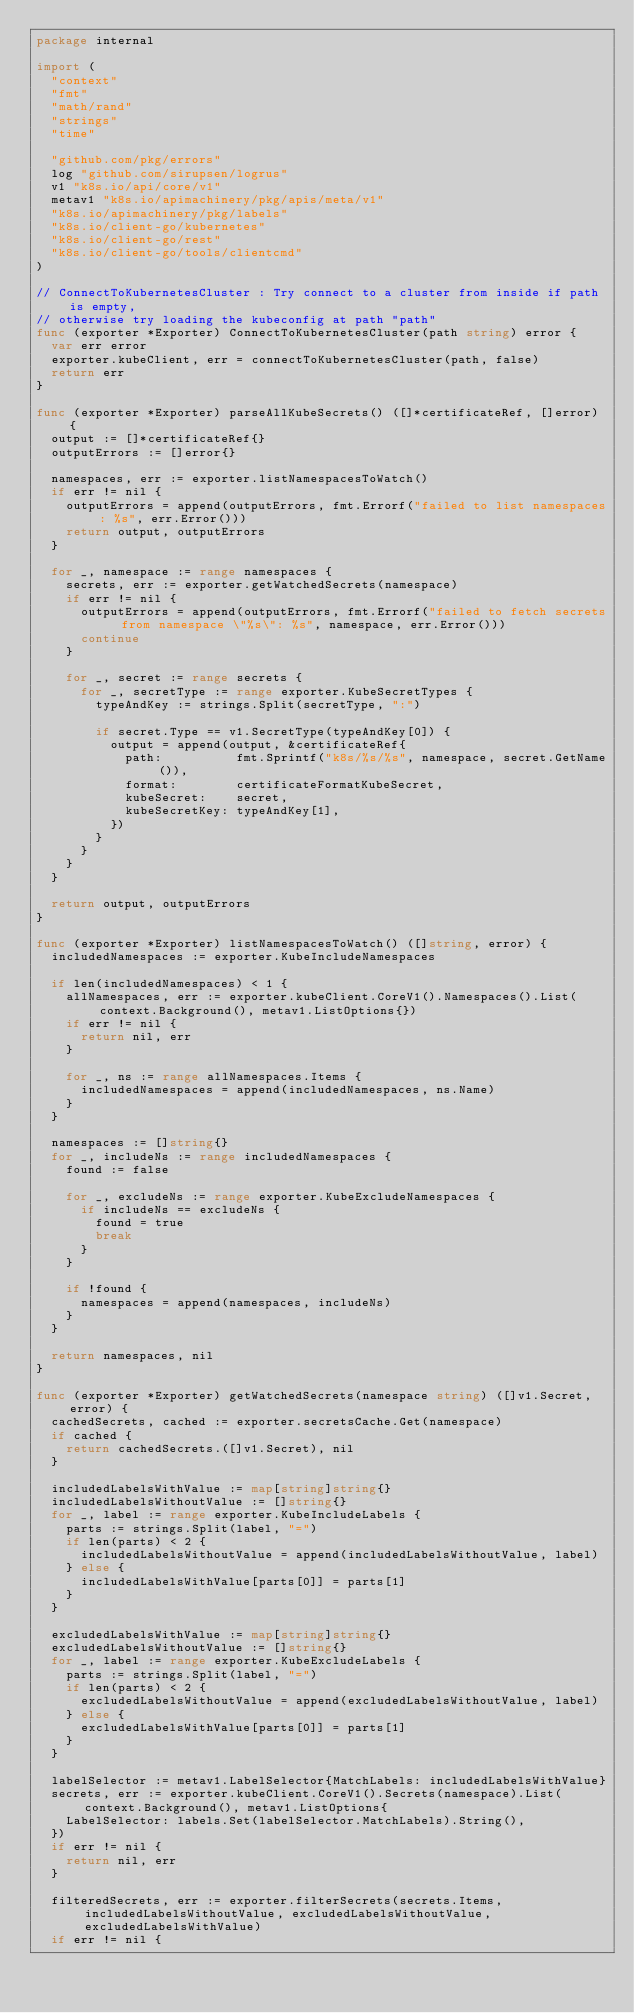<code> <loc_0><loc_0><loc_500><loc_500><_Go_>package internal

import (
	"context"
	"fmt"
	"math/rand"
	"strings"
	"time"

	"github.com/pkg/errors"
	log "github.com/sirupsen/logrus"
	v1 "k8s.io/api/core/v1"
	metav1 "k8s.io/apimachinery/pkg/apis/meta/v1"
	"k8s.io/apimachinery/pkg/labels"
	"k8s.io/client-go/kubernetes"
	"k8s.io/client-go/rest"
	"k8s.io/client-go/tools/clientcmd"
)

// ConnectToKubernetesCluster : Try connect to a cluster from inside if path is empty,
// otherwise try loading the kubeconfig at path "path"
func (exporter *Exporter) ConnectToKubernetesCluster(path string) error {
	var err error
	exporter.kubeClient, err = connectToKubernetesCluster(path, false)
	return err
}

func (exporter *Exporter) parseAllKubeSecrets() ([]*certificateRef, []error) {
	output := []*certificateRef{}
	outputErrors := []error{}

	namespaces, err := exporter.listNamespacesToWatch()
	if err != nil {
		outputErrors = append(outputErrors, fmt.Errorf("failed to list namespaces: %s", err.Error()))
		return output, outputErrors
	}

	for _, namespace := range namespaces {
		secrets, err := exporter.getWatchedSecrets(namespace)
		if err != nil {
			outputErrors = append(outputErrors, fmt.Errorf("failed to fetch secrets from namespace \"%s\": %s", namespace, err.Error()))
			continue
		}

		for _, secret := range secrets {
			for _, secretType := range exporter.KubeSecretTypes {
				typeAndKey := strings.Split(secretType, ":")

				if secret.Type == v1.SecretType(typeAndKey[0]) {
					output = append(output, &certificateRef{
						path:          fmt.Sprintf("k8s/%s/%s", namespace, secret.GetName()),
						format:        certificateFormatKubeSecret,
						kubeSecret:    secret,
						kubeSecretKey: typeAndKey[1],
					})
				}
			}
		}
	}

	return output, outputErrors
}

func (exporter *Exporter) listNamespacesToWatch() ([]string, error) {
	includedNamespaces := exporter.KubeIncludeNamespaces

	if len(includedNamespaces) < 1 {
		allNamespaces, err := exporter.kubeClient.CoreV1().Namespaces().List(context.Background(), metav1.ListOptions{})
		if err != nil {
			return nil, err
		}

		for _, ns := range allNamespaces.Items {
			includedNamespaces = append(includedNamespaces, ns.Name)
		}
	}

	namespaces := []string{}
	for _, includeNs := range includedNamespaces {
		found := false

		for _, excludeNs := range exporter.KubeExcludeNamespaces {
			if includeNs == excludeNs {
				found = true
				break
			}
		}

		if !found {
			namespaces = append(namespaces, includeNs)
		}
	}

	return namespaces, nil
}

func (exporter *Exporter) getWatchedSecrets(namespace string) ([]v1.Secret, error) {
	cachedSecrets, cached := exporter.secretsCache.Get(namespace)
	if cached {
		return cachedSecrets.([]v1.Secret), nil
	}

	includedLabelsWithValue := map[string]string{}
	includedLabelsWithoutValue := []string{}
	for _, label := range exporter.KubeIncludeLabels {
		parts := strings.Split(label, "=")
		if len(parts) < 2 {
			includedLabelsWithoutValue = append(includedLabelsWithoutValue, label)
		} else {
			includedLabelsWithValue[parts[0]] = parts[1]
		}
	}

	excludedLabelsWithValue := map[string]string{}
	excludedLabelsWithoutValue := []string{}
	for _, label := range exporter.KubeExcludeLabels {
		parts := strings.Split(label, "=")
		if len(parts) < 2 {
			excludedLabelsWithoutValue = append(excludedLabelsWithoutValue, label)
		} else {
			excludedLabelsWithValue[parts[0]] = parts[1]
		}
	}

	labelSelector := metav1.LabelSelector{MatchLabels: includedLabelsWithValue}
	secrets, err := exporter.kubeClient.CoreV1().Secrets(namespace).List(context.Background(), metav1.ListOptions{
		LabelSelector: labels.Set(labelSelector.MatchLabels).String(),
	})
	if err != nil {
		return nil, err
	}

	filteredSecrets, err := exporter.filterSecrets(secrets.Items, includedLabelsWithoutValue, excludedLabelsWithoutValue, excludedLabelsWithValue)
	if err != nil {</code> 